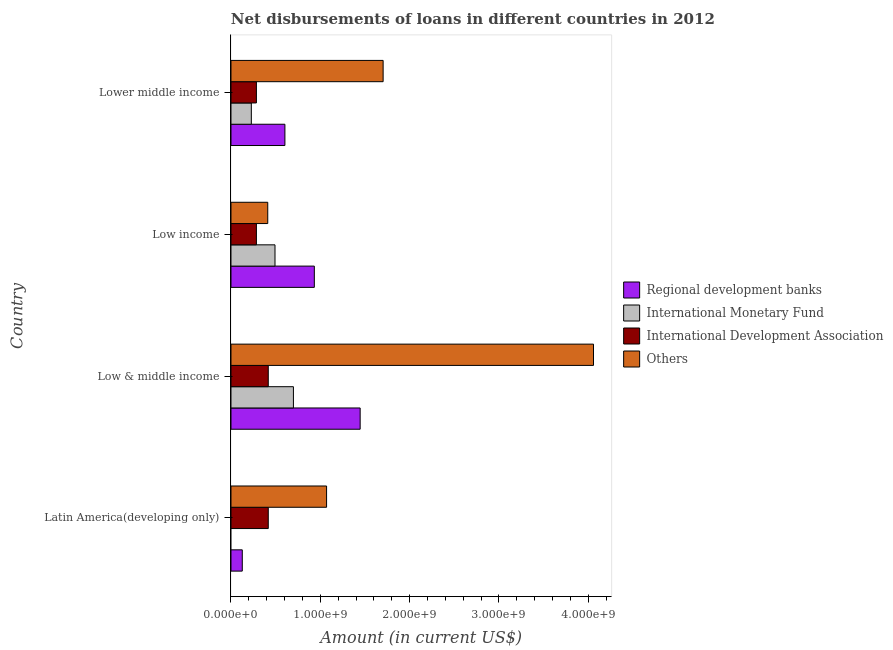How many different coloured bars are there?
Provide a short and direct response. 4. How many groups of bars are there?
Keep it short and to the point. 4. How many bars are there on the 1st tick from the top?
Provide a succinct answer. 4. What is the label of the 1st group of bars from the top?
Give a very brief answer. Lower middle income. In how many cases, is the number of bars for a given country not equal to the number of legend labels?
Provide a succinct answer. 1. What is the amount of loan disimbursed by other organisations in Latin America(developing only)?
Make the answer very short. 1.07e+09. Across all countries, what is the maximum amount of loan disimbursed by other organisations?
Give a very brief answer. 4.06e+09. Across all countries, what is the minimum amount of loan disimbursed by international development association?
Offer a terse response. 2.85e+08. In which country was the amount of loan disimbursed by international development association maximum?
Provide a short and direct response. Latin America(developing only). What is the total amount of loan disimbursed by regional development banks in the graph?
Your response must be concise. 3.11e+09. What is the difference between the amount of loan disimbursed by international development association in Latin America(developing only) and that in Lower middle income?
Your answer should be very brief. 1.33e+08. What is the difference between the amount of loan disimbursed by regional development banks in Low & middle income and the amount of loan disimbursed by international monetary fund in Low income?
Offer a very short reply. 9.53e+08. What is the average amount of loan disimbursed by international development association per country?
Make the answer very short. 3.51e+08. What is the difference between the amount of loan disimbursed by international monetary fund and amount of loan disimbursed by regional development banks in Lower middle income?
Your answer should be very brief. -3.76e+08. What is the ratio of the amount of loan disimbursed by other organisations in Low & middle income to that in Lower middle income?
Your answer should be compact. 2.38. Is the amount of loan disimbursed by regional development banks in Low & middle income less than that in Lower middle income?
Offer a terse response. No. Is the difference between the amount of loan disimbursed by international development association in Latin America(developing only) and Low & middle income greater than the difference between the amount of loan disimbursed by regional development banks in Latin America(developing only) and Low & middle income?
Provide a short and direct response. Yes. What is the difference between the highest and the second highest amount of loan disimbursed by international monetary fund?
Ensure brevity in your answer.  2.06e+08. What is the difference between the highest and the lowest amount of loan disimbursed by other organisations?
Your answer should be compact. 3.65e+09. In how many countries, is the amount of loan disimbursed by international development association greater than the average amount of loan disimbursed by international development association taken over all countries?
Provide a short and direct response. 2. Is it the case that in every country, the sum of the amount of loan disimbursed by regional development banks and amount of loan disimbursed by international monetary fund is greater than the sum of amount of loan disimbursed by other organisations and amount of loan disimbursed by international development association?
Your response must be concise. No. How many bars are there?
Ensure brevity in your answer.  15. How many countries are there in the graph?
Offer a terse response. 4. Does the graph contain any zero values?
Ensure brevity in your answer.  Yes. Where does the legend appear in the graph?
Your answer should be very brief. Center right. What is the title of the graph?
Provide a succinct answer. Net disbursements of loans in different countries in 2012. What is the Amount (in current US$) in Regional development banks in Latin America(developing only)?
Give a very brief answer. 1.27e+08. What is the Amount (in current US$) in International Monetary Fund in Latin America(developing only)?
Make the answer very short. 0. What is the Amount (in current US$) of International Development Association in Latin America(developing only)?
Offer a terse response. 4.17e+08. What is the Amount (in current US$) in Others in Latin America(developing only)?
Provide a short and direct response. 1.07e+09. What is the Amount (in current US$) of Regional development banks in Low & middle income?
Ensure brevity in your answer.  1.45e+09. What is the Amount (in current US$) in International Monetary Fund in Low & middle income?
Your answer should be very brief. 6.99e+08. What is the Amount (in current US$) in International Development Association in Low & middle income?
Offer a very short reply. 4.17e+08. What is the Amount (in current US$) of Others in Low & middle income?
Provide a short and direct response. 4.06e+09. What is the Amount (in current US$) of Regional development banks in Low income?
Your answer should be compact. 9.33e+08. What is the Amount (in current US$) of International Monetary Fund in Low income?
Make the answer very short. 4.93e+08. What is the Amount (in current US$) in International Development Association in Low income?
Make the answer very short. 2.85e+08. What is the Amount (in current US$) in Others in Low income?
Provide a succinct answer. 4.12e+08. What is the Amount (in current US$) in Regional development banks in Lower middle income?
Provide a short and direct response. 6.04e+08. What is the Amount (in current US$) in International Monetary Fund in Lower middle income?
Keep it short and to the point. 2.28e+08. What is the Amount (in current US$) of International Development Association in Lower middle income?
Provide a succinct answer. 2.85e+08. What is the Amount (in current US$) of Others in Lower middle income?
Ensure brevity in your answer.  1.70e+09. Across all countries, what is the maximum Amount (in current US$) of Regional development banks?
Make the answer very short. 1.45e+09. Across all countries, what is the maximum Amount (in current US$) of International Monetary Fund?
Offer a very short reply. 6.99e+08. Across all countries, what is the maximum Amount (in current US$) in International Development Association?
Make the answer very short. 4.17e+08. Across all countries, what is the maximum Amount (in current US$) of Others?
Your answer should be compact. 4.06e+09. Across all countries, what is the minimum Amount (in current US$) of Regional development banks?
Your answer should be very brief. 1.27e+08. Across all countries, what is the minimum Amount (in current US$) of International Monetary Fund?
Give a very brief answer. 0. Across all countries, what is the minimum Amount (in current US$) of International Development Association?
Offer a very short reply. 2.85e+08. Across all countries, what is the minimum Amount (in current US$) in Others?
Your response must be concise. 4.12e+08. What is the total Amount (in current US$) of Regional development banks in the graph?
Make the answer very short. 3.11e+09. What is the total Amount (in current US$) of International Monetary Fund in the graph?
Provide a succinct answer. 1.42e+09. What is the total Amount (in current US$) of International Development Association in the graph?
Provide a succinct answer. 1.40e+09. What is the total Amount (in current US$) in Others in the graph?
Keep it short and to the point. 7.24e+09. What is the difference between the Amount (in current US$) in Regional development banks in Latin America(developing only) and that in Low & middle income?
Provide a succinct answer. -1.32e+09. What is the difference between the Amount (in current US$) of International Development Association in Latin America(developing only) and that in Low & middle income?
Offer a very short reply. 0. What is the difference between the Amount (in current US$) of Others in Latin America(developing only) and that in Low & middle income?
Your answer should be very brief. -2.99e+09. What is the difference between the Amount (in current US$) in Regional development banks in Latin America(developing only) and that in Low income?
Your answer should be very brief. -8.06e+08. What is the difference between the Amount (in current US$) of International Development Association in Latin America(developing only) and that in Low income?
Offer a very short reply. 1.33e+08. What is the difference between the Amount (in current US$) of Others in Latin America(developing only) and that in Low income?
Offer a terse response. 6.59e+08. What is the difference between the Amount (in current US$) of Regional development banks in Latin America(developing only) and that in Lower middle income?
Give a very brief answer. -4.77e+08. What is the difference between the Amount (in current US$) of International Development Association in Latin America(developing only) and that in Lower middle income?
Provide a short and direct response. 1.33e+08. What is the difference between the Amount (in current US$) of Others in Latin America(developing only) and that in Lower middle income?
Provide a short and direct response. -6.33e+08. What is the difference between the Amount (in current US$) in Regional development banks in Low & middle income and that in Low income?
Offer a very short reply. 5.13e+08. What is the difference between the Amount (in current US$) in International Monetary Fund in Low & middle income and that in Low income?
Make the answer very short. 2.06e+08. What is the difference between the Amount (in current US$) of International Development Association in Low & middle income and that in Low income?
Ensure brevity in your answer.  1.33e+08. What is the difference between the Amount (in current US$) in Others in Low & middle income and that in Low income?
Provide a succinct answer. 3.65e+09. What is the difference between the Amount (in current US$) in Regional development banks in Low & middle income and that in Lower middle income?
Make the answer very short. 8.42e+08. What is the difference between the Amount (in current US$) of International Monetary Fund in Low & middle income and that in Lower middle income?
Your answer should be very brief. 4.71e+08. What is the difference between the Amount (in current US$) in International Development Association in Low & middle income and that in Lower middle income?
Your answer should be very brief. 1.33e+08. What is the difference between the Amount (in current US$) in Others in Low & middle income and that in Lower middle income?
Provide a succinct answer. 2.36e+09. What is the difference between the Amount (in current US$) in Regional development banks in Low income and that in Lower middle income?
Your answer should be very brief. 3.29e+08. What is the difference between the Amount (in current US$) in International Monetary Fund in Low income and that in Lower middle income?
Provide a succinct answer. 2.65e+08. What is the difference between the Amount (in current US$) in Others in Low income and that in Lower middle income?
Keep it short and to the point. -1.29e+09. What is the difference between the Amount (in current US$) in Regional development banks in Latin America(developing only) and the Amount (in current US$) in International Monetary Fund in Low & middle income?
Provide a short and direct response. -5.72e+08. What is the difference between the Amount (in current US$) of Regional development banks in Latin America(developing only) and the Amount (in current US$) of International Development Association in Low & middle income?
Keep it short and to the point. -2.91e+08. What is the difference between the Amount (in current US$) in Regional development banks in Latin America(developing only) and the Amount (in current US$) in Others in Low & middle income?
Make the answer very short. -3.93e+09. What is the difference between the Amount (in current US$) of International Development Association in Latin America(developing only) and the Amount (in current US$) of Others in Low & middle income?
Keep it short and to the point. -3.64e+09. What is the difference between the Amount (in current US$) of Regional development banks in Latin America(developing only) and the Amount (in current US$) of International Monetary Fund in Low income?
Your response must be concise. -3.66e+08. What is the difference between the Amount (in current US$) of Regional development banks in Latin America(developing only) and the Amount (in current US$) of International Development Association in Low income?
Your answer should be very brief. -1.58e+08. What is the difference between the Amount (in current US$) in Regional development banks in Latin America(developing only) and the Amount (in current US$) in Others in Low income?
Offer a very short reply. -2.85e+08. What is the difference between the Amount (in current US$) in International Development Association in Latin America(developing only) and the Amount (in current US$) in Others in Low income?
Offer a terse response. 5.72e+06. What is the difference between the Amount (in current US$) in Regional development banks in Latin America(developing only) and the Amount (in current US$) in International Monetary Fund in Lower middle income?
Your response must be concise. -1.01e+08. What is the difference between the Amount (in current US$) in Regional development banks in Latin America(developing only) and the Amount (in current US$) in International Development Association in Lower middle income?
Your answer should be very brief. -1.58e+08. What is the difference between the Amount (in current US$) in Regional development banks in Latin America(developing only) and the Amount (in current US$) in Others in Lower middle income?
Give a very brief answer. -1.58e+09. What is the difference between the Amount (in current US$) of International Development Association in Latin America(developing only) and the Amount (in current US$) of Others in Lower middle income?
Keep it short and to the point. -1.29e+09. What is the difference between the Amount (in current US$) of Regional development banks in Low & middle income and the Amount (in current US$) of International Monetary Fund in Low income?
Your answer should be very brief. 9.53e+08. What is the difference between the Amount (in current US$) of Regional development banks in Low & middle income and the Amount (in current US$) of International Development Association in Low income?
Ensure brevity in your answer.  1.16e+09. What is the difference between the Amount (in current US$) of Regional development banks in Low & middle income and the Amount (in current US$) of Others in Low income?
Your answer should be compact. 1.03e+09. What is the difference between the Amount (in current US$) of International Monetary Fund in Low & middle income and the Amount (in current US$) of International Development Association in Low income?
Ensure brevity in your answer.  4.14e+08. What is the difference between the Amount (in current US$) in International Monetary Fund in Low & middle income and the Amount (in current US$) in Others in Low income?
Your answer should be very brief. 2.87e+08. What is the difference between the Amount (in current US$) of International Development Association in Low & middle income and the Amount (in current US$) of Others in Low income?
Ensure brevity in your answer.  5.72e+06. What is the difference between the Amount (in current US$) of Regional development banks in Low & middle income and the Amount (in current US$) of International Monetary Fund in Lower middle income?
Provide a succinct answer. 1.22e+09. What is the difference between the Amount (in current US$) of Regional development banks in Low & middle income and the Amount (in current US$) of International Development Association in Lower middle income?
Ensure brevity in your answer.  1.16e+09. What is the difference between the Amount (in current US$) of Regional development banks in Low & middle income and the Amount (in current US$) of Others in Lower middle income?
Your response must be concise. -2.57e+08. What is the difference between the Amount (in current US$) of International Monetary Fund in Low & middle income and the Amount (in current US$) of International Development Association in Lower middle income?
Offer a terse response. 4.14e+08. What is the difference between the Amount (in current US$) of International Monetary Fund in Low & middle income and the Amount (in current US$) of Others in Lower middle income?
Your answer should be compact. -1.00e+09. What is the difference between the Amount (in current US$) of International Development Association in Low & middle income and the Amount (in current US$) of Others in Lower middle income?
Offer a very short reply. -1.29e+09. What is the difference between the Amount (in current US$) of Regional development banks in Low income and the Amount (in current US$) of International Monetary Fund in Lower middle income?
Your answer should be very brief. 7.05e+08. What is the difference between the Amount (in current US$) of Regional development banks in Low income and the Amount (in current US$) of International Development Association in Lower middle income?
Keep it short and to the point. 6.48e+08. What is the difference between the Amount (in current US$) of Regional development banks in Low income and the Amount (in current US$) of Others in Lower middle income?
Your answer should be very brief. -7.70e+08. What is the difference between the Amount (in current US$) in International Monetary Fund in Low income and the Amount (in current US$) in International Development Association in Lower middle income?
Your answer should be very brief. 2.08e+08. What is the difference between the Amount (in current US$) of International Monetary Fund in Low income and the Amount (in current US$) of Others in Lower middle income?
Provide a short and direct response. -1.21e+09. What is the difference between the Amount (in current US$) of International Development Association in Low income and the Amount (in current US$) of Others in Lower middle income?
Make the answer very short. -1.42e+09. What is the average Amount (in current US$) of Regional development banks per country?
Your answer should be compact. 7.77e+08. What is the average Amount (in current US$) in International Monetary Fund per country?
Your answer should be compact. 3.55e+08. What is the average Amount (in current US$) of International Development Association per country?
Provide a short and direct response. 3.51e+08. What is the average Amount (in current US$) in Others per country?
Your answer should be very brief. 1.81e+09. What is the difference between the Amount (in current US$) in Regional development banks and Amount (in current US$) in International Development Association in Latin America(developing only)?
Provide a succinct answer. -2.91e+08. What is the difference between the Amount (in current US$) in Regional development banks and Amount (in current US$) in Others in Latin America(developing only)?
Give a very brief answer. -9.44e+08. What is the difference between the Amount (in current US$) in International Development Association and Amount (in current US$) in Others in Latin America(developing only)?
Offer a terse response. -6.53e+08. What is the difference between the Amount (in current US$) in Regional development banks and Amount (in current US$) in International Monetary Fund in Low & middle income?
Make the answer very short. 7.47e+08. What is the difference between the Amount (in current US$) in Regional development banks and Amount (in current US$) in International Development Association in Low & middle income?
Provide a short and direct response. 1.03e+09. What is the difference between the Amount (in current US$) in Regional development banks and Amount (in current US$) in Others in Low & middle income?
Provide a short and direct response. -2.61e+09. What is the difference between the Amount (in current US$) of International Monetary Fund and Amount (in current US$) of International Development Association in Low & middle income?
Give a very brief answer. 2.82e+08. What is the difference between the Amount (in current US$) in International Monetary Fund and Amount (in current US$) in Others in Low & middle income?
Provide a short and direct response. -3.36e+09. What is the difference between the Amount (in current US$) of International Development Association and Amount (in current US$) of Others in Low & middle income?
Keep it short and to the point. -3.64e+09. What is the difference between the Amount (in current US$) of Regional development banks and Amount (in current US$) of International Monetary Fund in Low income?
Make the answer very short. 4.40e+08. What is the difference between the Amount (in current US$) in Regional development banks and Amount (in current US$) in International Development Association in Low income?
Your response must be concise. 6.48e+08. What is the difference between the Amount (in current US$) of Regional development banks and Amount (in current US$) of Others in Low income?
Offer a very short reply. 5.21e+08. What is the difference between the Amount (in current US$) of International Monetary Fund and Amount (in current US$) of International Development Association in Low income?
Offer a very short reply. 2.08e+08. What is the difference between the Amount (in current US$) in International Monetary Fund and Amount (in current US$) in Others in Low income?
Your answer should be very brief. 8.12e+07. What is the difference between the Amount (in current US$) in International Development Association and Amount (in current US$) in Others in Low income?
Ensure brevity in your answer.  -1.27e+08. What is the difference between the Amount (in current US$) in Regional development banks and Amount (in current US$) in International Monetary Fund in Lower middle income?
Ensure brevity in your answer.  3.76e+08. What is the difference between the Amount (in current US$) of Regional development banks and Amount (in current US$) of International Development Association in Lower middle income?
Your response must be concise. 3.19e+08. What is the difference between the Amount (in current US$) in Regional development banks and Amount (in current US$) in Others in Lower middle income?
Provide a succinct answer. -1.10e+09. What is the difference between the Amount (in current US$) of International Monetary Fund and Amount (in current US$) of International Development Association in Lower middle income?
Offer a terse response. -5.69e+07. What is the difference between the Amount (in current US$) of International Monetary Fund and Amount (in current US$) of Others in Lower middle income?
Offer a very short reply. -1.48e+09. What is the difference between the Amount (in current US$) of International Development Association and Amount (in current US$) of Others in Lower middle income?
Ensure brevity in your answer.  -1.42e+09. What is the ratio of the Amount (in current US$) of Regional development banks in Latin America(developing only) to that in Low & middle income?
Keep it short and to the point. 0.09. What is the ratio of the Amount (in current US$) in Others in Latin America(developing only) to that in Low & middle income?
Ensure brevity in your answer.  0.26. What is the ratio of the Amount (in current US$) of Regional development banks in Latin America(developing only) to that in Low income?
Ensure brevity in your answer.  0.14. What is the ratio of the Amount (in current US$) of International Development Association in Latin America(developing only) to that in Low income?
Keep it short and to the point. 1.47. What is the ratio of the Amount (in current US$) of Others in Latin America(developing only) to that in Low income?
Offer a very short reply. 2.6. What is the ratio of the Amount (in current US$) in Regional development banks in Latin America(developing only) to that in Lower middle income?
Offer a very short reply. 0.21. What is the ratio of the Amount (in current US$) in International Development Association in Latin America(developing only) to that in Lower middle income?
Your answer should be very brief. 1.47. What is the ratio of the Amount (in current US$) of Others in Latin America(developing only) to that in Lower middle income?
Your response must be concise. 0.63. What is the ratio of the Amount (in current US$) of Regional development banks in Low & middle income to that in Low income?
Your answer should be very brief. 1.55. What is the ratio of the Amount (in current US$) in International Monetary Fund in Low & middle income to that in Low income?
Provide a succinct answer. 1.42. What is the ratio of the Amount (in current US$) in International Development Association in Low & middle income to that in Low income?
Make the answer very short. 1.47. What is the ratio of the Amount (in current US$) in Others in Low & middle income to that in Low income?
Make the answer very short. 9.86. What is the ratio of the Amount (in current US$) of Regional development banks in Low & middle income to that in Lower middle income?
Give a very brief answer. 2.4. What is the ratio of the Amount (in current US$) of International Monetary Fund in Low & middle income to that in Lower middle income?
Make the answer very short. 3.07. What is the ratio of the Amount (in current US$) in International Development Association in Low & middle income to that in Lower middle income?
Offer a very short reply. 1.47. What is the ratio of the Amount (in current US$) of Others in Low & middle income to that in Lower middle income?
Offer a very short reply. 2.38. What is the ratio of the Amount (in current US$) in Regional development banks in Low income to that in Lower middle income?
Provide a short and direct response. 1.55. What is the ratio of the Amount (in current US$) of International Monetary Fund in Low income to that in Lower middle income?
Provide a succinct answer. 2.16. What is the ratio of the Amount (in current US$) in International Development Association in Low income to that in Lower middle income?
Your response must be concise. 1. What is the ratio of the Amount (in current US$) in Others in Low income to that in Lower middle income?
Offer a terse response. 0.24. What is the difference between the highest and the second highest Amount (in current US$) of Regional development banks?
Your answer should be very brief. 5.13e+08. What is the difference between the highest and the second highest Amount (in current US$) of International Monetary Fund?
Your answer should be very brief. 2.06e+08. What is the difference between the highest and the second highest Amount (in current US$) of Others?
Give a very brief answer. 2.36e+09. What is the difference between the highest and the lowest Amount (in current US$) in Regional development banks?
Your answer should be compact. 1.32e+09. What is the difference between the highest and the lowest Amount (in current US$) of International Monetary Fund?
Offer a very short reply. 6.99e+08. What is the difference between the highest and the lowest Amount (in current US$) in International Development Association?
Ensure brevity in your answer.  1.33e+08. What is the difference between the highest and the lowest Amount (in current US$) in Others?
Offer a very short reply. 3.65e+09. 